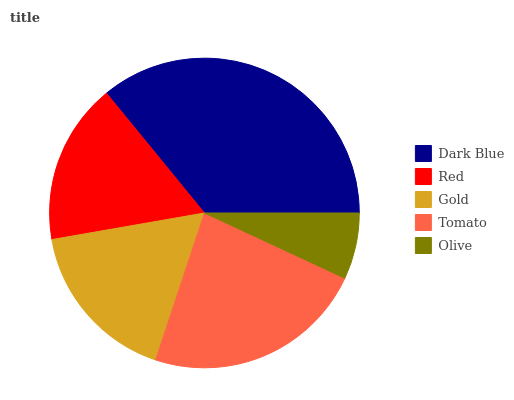Is Olive the minimum?
Answer yes or no. Yes. Is Dark Blue the maximum?
Answer yes or no. Yes. Is Red the minimum?
Answer yes or no. No. Is Red the maximum?
Answer yes or no. No. Is Dark Blue greater than Red?
Answer yes or no. Yes. Is Red less than Dark Blue?
Answer yes or no. Yes. Is Red greater than Dark Blue?
Answer yes or no. No. Is Dark Blue less than Red?
Answer yes or no. No. Is Gold the high median?
Answer yes or no. Yes. Is Gold the low median?
Answer yes or no. Yes. Is Dark Blue the high median?
Answer yes or no. No. Is Olive the low median?
Answer yes or no. No. 